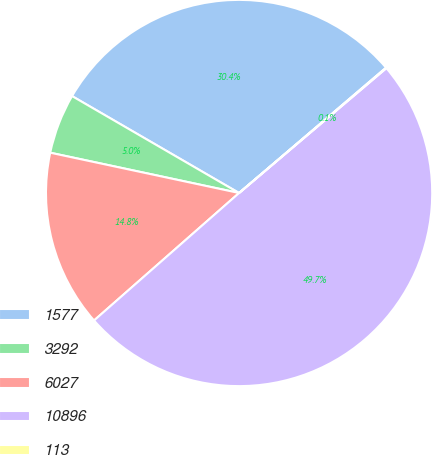<chart> <loc_0><loc_0><loc_500><loc_500><pie_chart><fcel>1577<fcel>3292<fcel>6027<fcel>10896<fcel>113<nl><fcel>30.39%<fcel>5.02%<fcel>14.82%<fcel>49.71%<fcel>0.05%<nl></chart> 